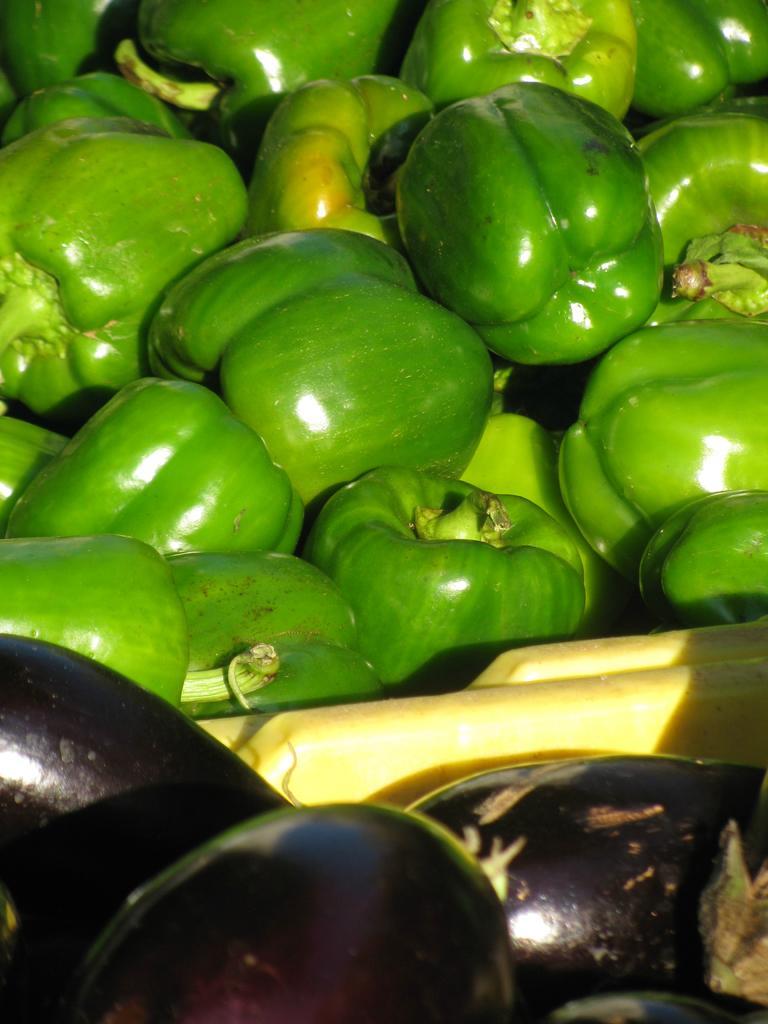Describe this image in one or two sentences. In this image there are some capsicums and brinjals. 